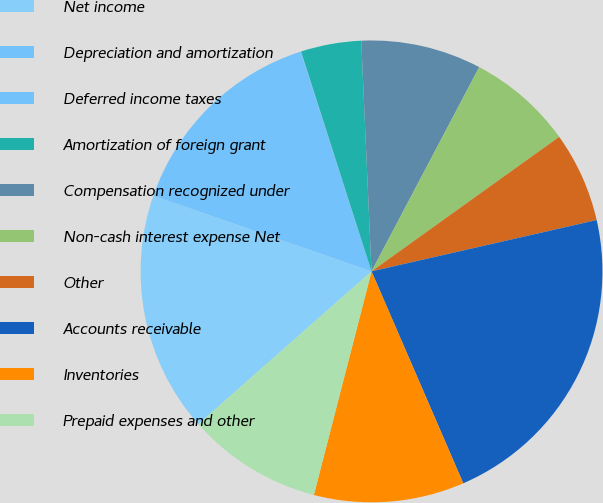Convert chart. <chart><loc_0><loc_0><loc_500><loc_500><pie_chart><fcel>Net income<fcel>Depreciation and amortization<fcel>Deferred income taxes<fcel>Amortization of foreign grant<fcel>Compensation recognized under<fcel>Non-cash interest expense Net<fcel>Other<fcel>Accounts receivable<fcel>Inventories<fcel>Prepaid expenses and other<nl><fcel>16.82%<fcel>14.72%<fcel>0.03%<fcel>4.23%<fcel>8.43%<fcel>7.38%<fcel>6.33%<fcel>22.07%<fcel>10.52%<fcel>9.48%<nl></chart> 